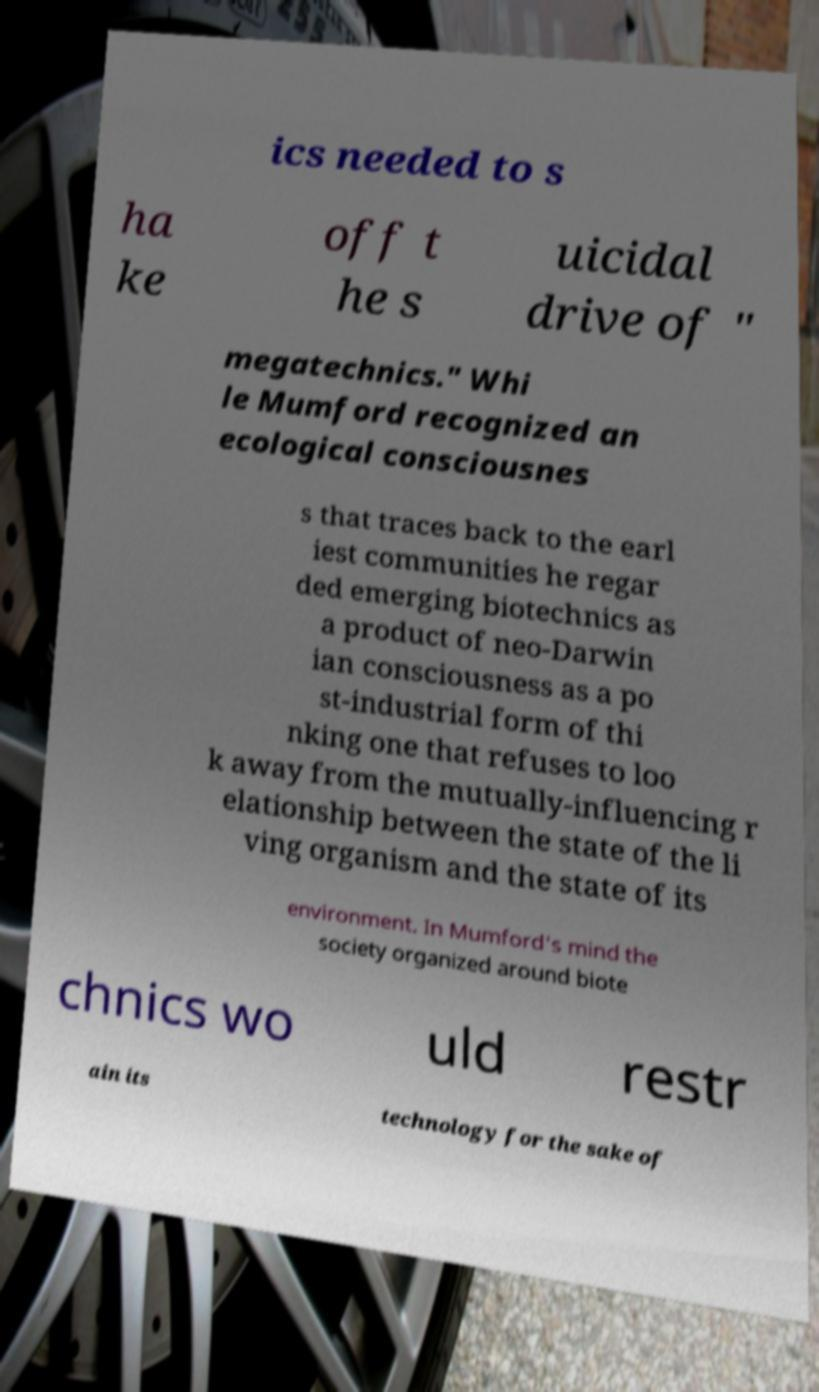Could you extract and type out the text from this image? ics needed to s ha ke off t he s uicidal drive of " megatechnics." Whi le Mumford recognized an ecological consciousnes s that traces back to the earl iest communities he regar ded emerging biotechnics as a product of neo-Darwin ian consciousness as a po st-industrial form of thi nking one that refuses to loo k away from the mutually-influencing r elationship between the state of the li ving organism and the state of its environment. In Mumford's mind the society organized around biote chnics wo uld restr ain its technology for the sake of 